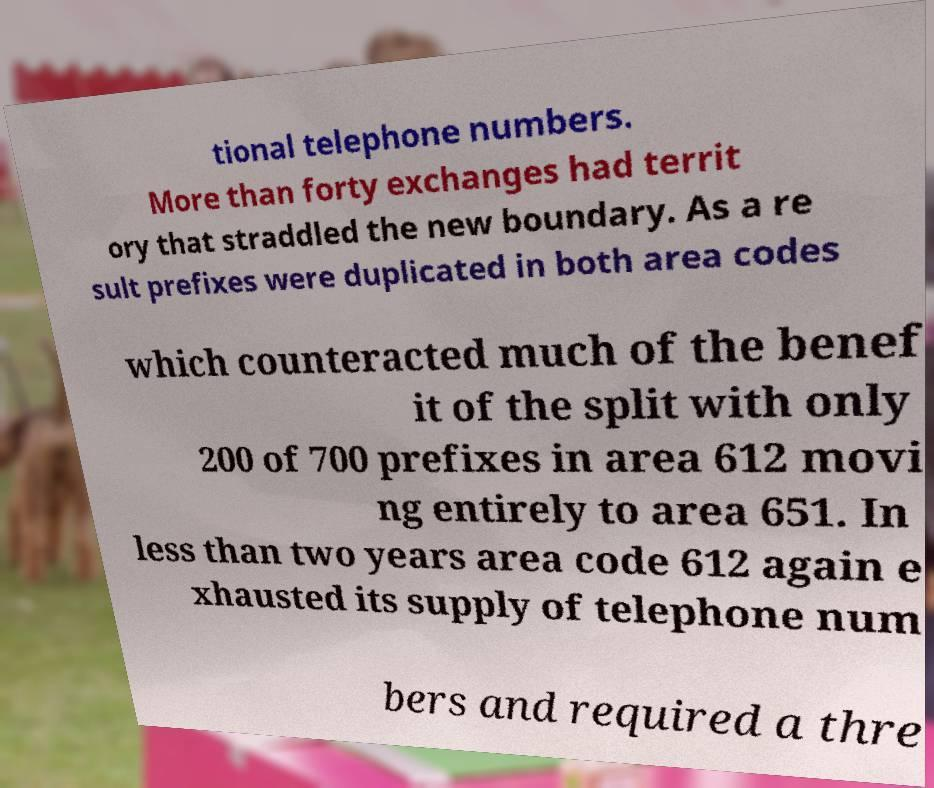Can you accurately transcribe the text from the provided image for me? tional telephone numbers. More than forty exchanges had territ ory that straddled the new boundary. As a re sult prefixes were duplicated in both area codes which counteracted much of the benef it of the split with only 200 of 700 prefixes in area 612 movi ng entirely to area 651. In less than two years area code 612 again e xhausted its supply of telephone num bers and required a thre 